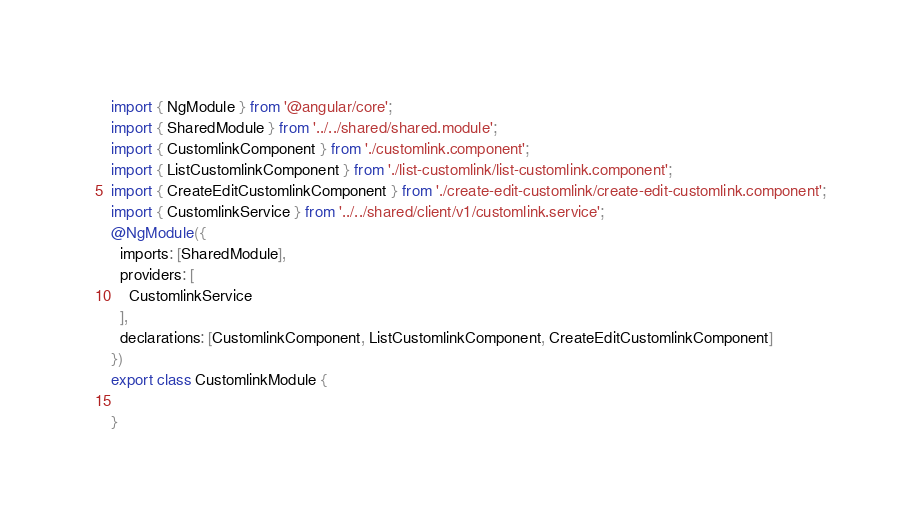<code> <loc_0><loc_0><loc_500><loc_500><_TypeScript_>import { NgModule } from '@angular/core';
import { SharedModule } from '../../shared/shared.module';
import { CustomlinkComponent } from './customlink.component';
import { ListCustomlinkComponent } from './list-customlink/list-customlink.component';
import { CreateEditCustomlinkComponent } from './create-edit-customlink/create-edit-customlink.component';
import { CustomlinkService } from '../../shared/client/v1/customlink.service';
@NgModule({
  imports: [SharedModule],
  providers: [
    CustomlinkService
  ],
  declarations: [CustomlinkComponent, ListCustomlinkComponent, CreateEditCustomlinkComponent]
})
export class CustomlinkModule {

}
</code> 